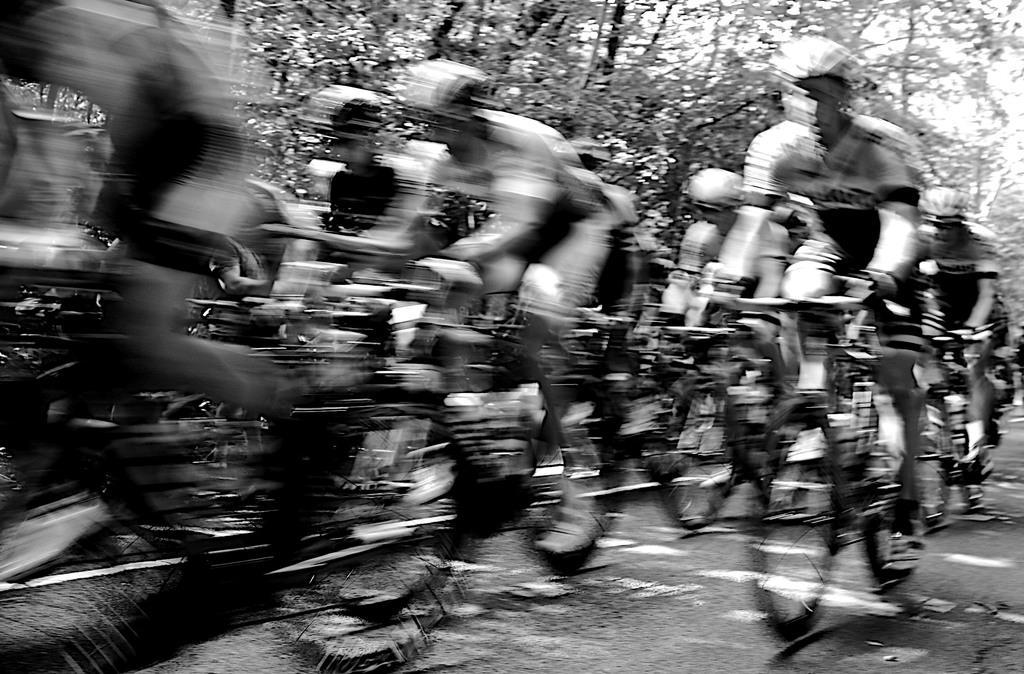Could you give a brief overview of what you see in this image? This is a black and white picture. In this picture we can see a few people riding on the bicycles. There is a blur view on the left side. We can see a few trees in the background. 